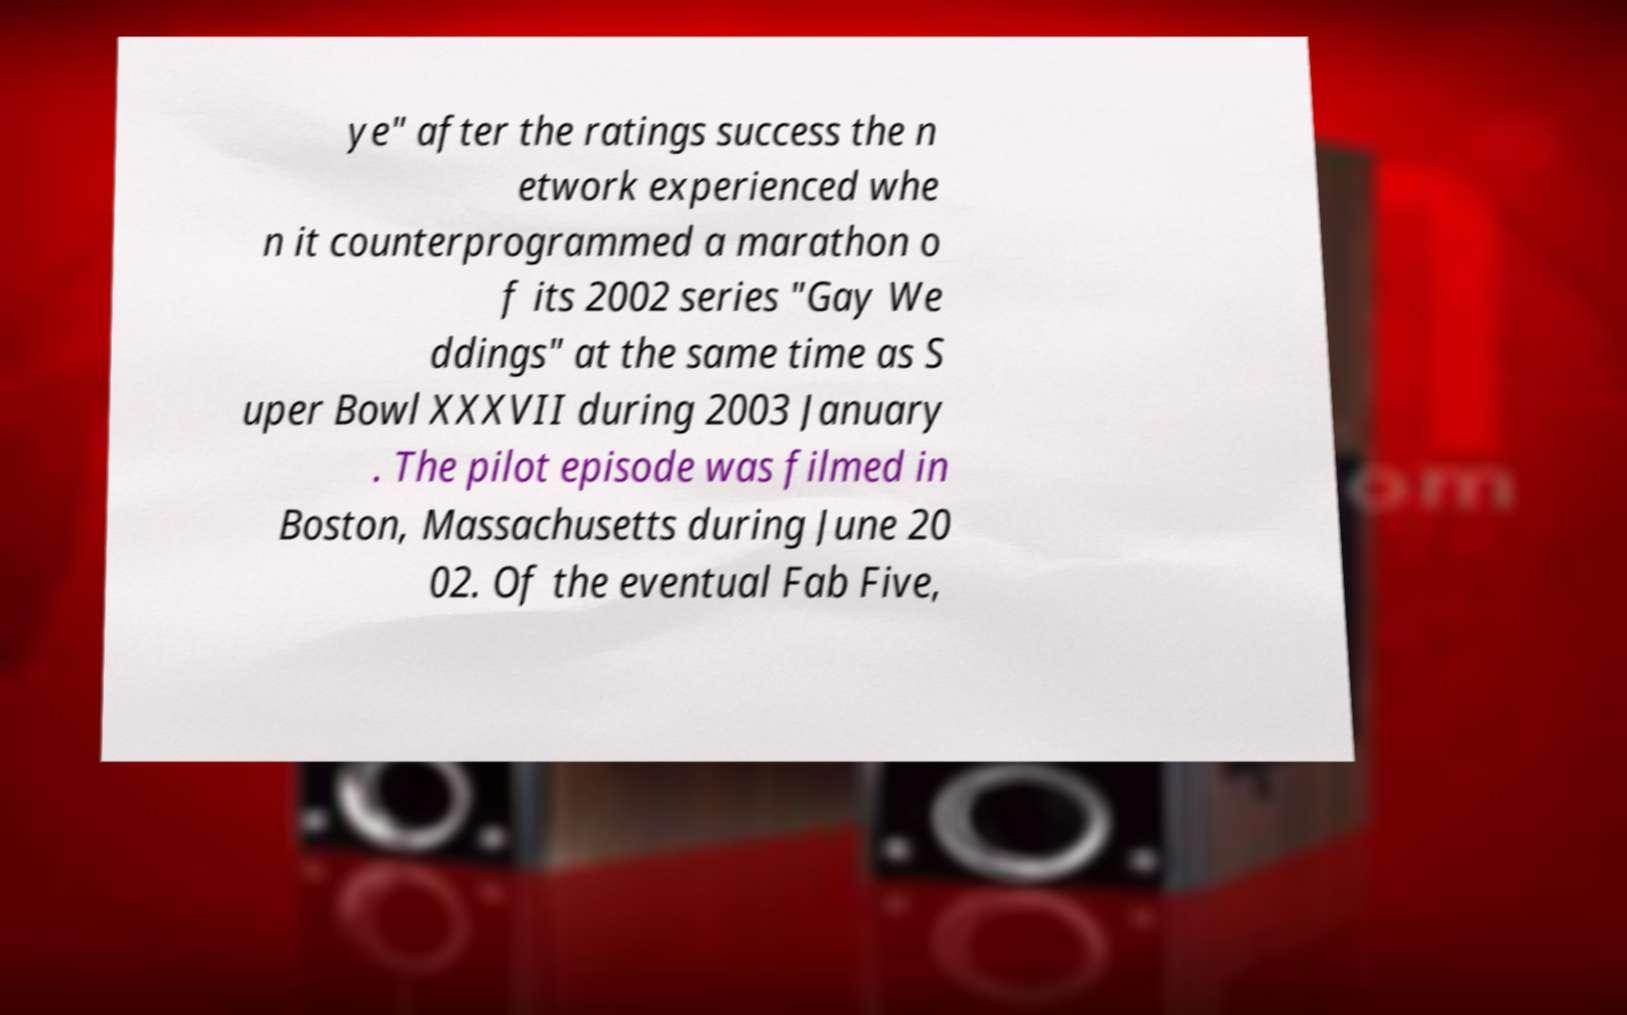What messages or text are displayed in this image? I need them in a readable, typed format. ye" after the ratings success the n etwork experienced whe n it counterprogrammed a marathon o f its 2002 series "Gay We ddings" at the same time as S uper Bowl XXXVII during 2003 January . The pilot episode was filmed in Boston, Massachusetts during June 20 02. Of the eventual Fab Five, 